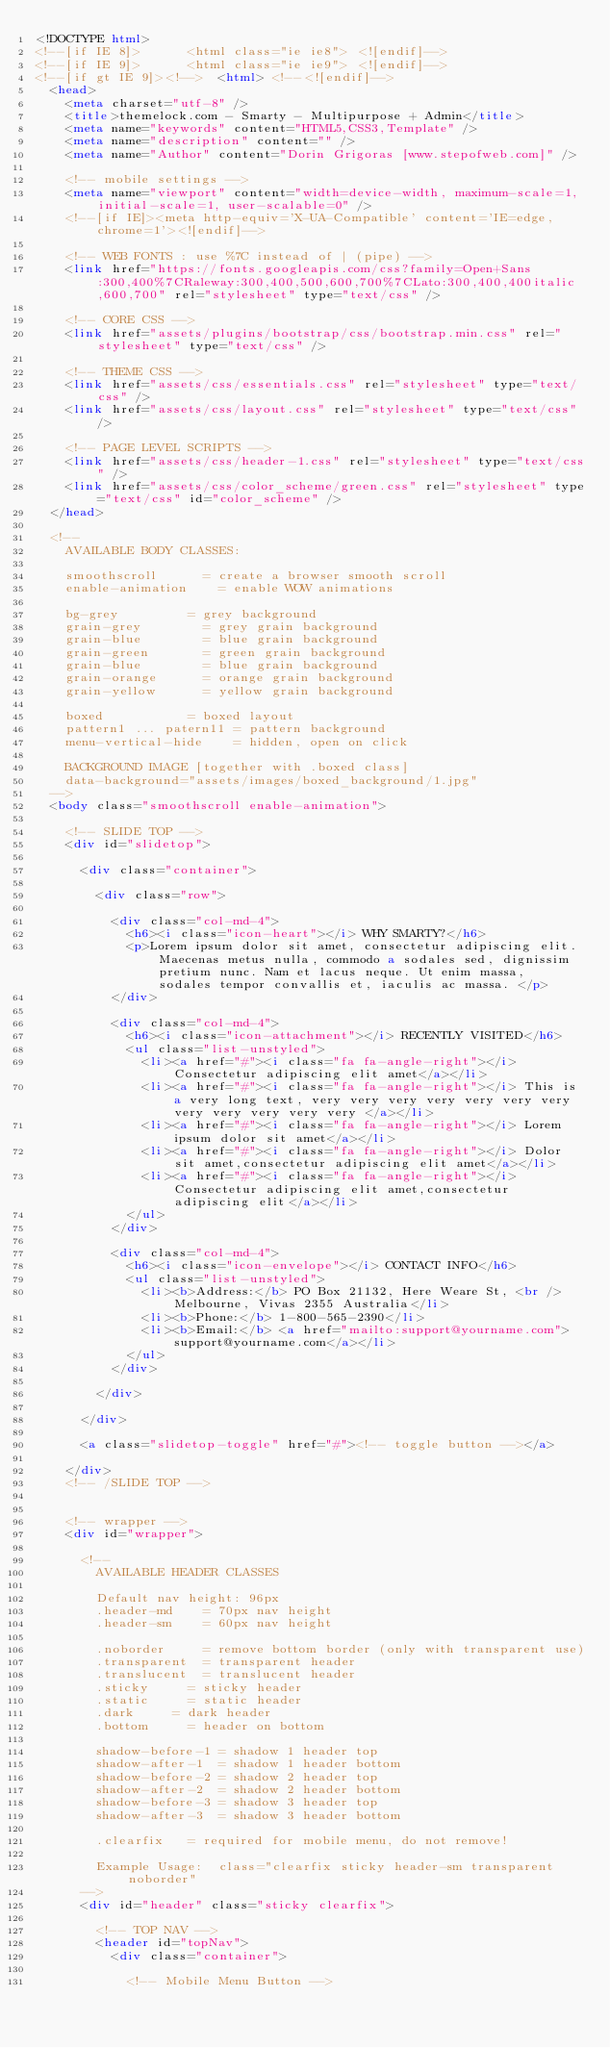Convert code to text. <code><loc_0><loc_0><loc_500><loc_500><_HTML_><!DOCTYPE html>
<!--[if IE 8]>			<html class="ie ie8"> <![endif]-->
<!--[if IE 9]>			<html class="ie ie9"> <![endif]-->
<!--[if gt IE 9]><!-->	<html> <!--<![endif]-->
	<head>
		<meta charset="utf-8" />
		<title>themelock.com - Smarty - Multipurpose + Admin</title>
		<meta name="keywords" content="HTML5,CSS3,Template" />
		<meta name="description" content="" />
		<meta name="Author" content="Dorin Grigoras [www.stepofweb.com]" />

		<!-- mobile settings -->
		<meta name="viewport" content="width=device-width, maximum-scale=1, initial-scale=1, user-scalable=0" />
		<!--[if IE]><meta http-equiv='X-UA-Compatible' content='IE=edge,chrome=1'><![endif]-->

		<!-- WEB FONTS : use %7C instead of | (pipe) -->
		<link href="https://fonts.googleapis.com/css?family=Open+Sans:300,400%7CRaleway:300,400,500,600,700%7CLato:300,400,400italic,600,700" rel="stylesheet" type="text/css" />

		<!-- CORE CSS -->
		<link href="assets/plugins/bootstrap/css/bootstrap.min.css" rel="stylesheet" type="text/css" />
		
		<!-- THEME CSS -->
		<link href="assets/css/essentials.css" rel="stylesheet" type="text/css" />
		<link href="assets/css/layout.css" rel="stylesheet" type="text/css" />

		<!-- PAGE LEVEL SCRIPTS -->
		<link href="assets/css/header-1.css" rel="stylesheet" type="text/css" />
		<link href="assets/css/color_scheme/green.css" rel="stylesheet" type="text/css" id="color_scheme" />
	</head>

	<!--
		AVAILABLE BODY CLASSES:
		
		smoothscroll 			= create a browser smooth scroll
		enable-animation		= enable WOW animations

		bg-grey					= grey background
		grain-grey				= grey grain background
		grain-blue				= blue grain background
		grain-green				= green grain background
		grain-blue				= blue grain background
		grain-orange			= orange grain background
		grain-yellow			= yellow grain background
		
		boxed 					= boxed layout
		pattern1 ... patern11	= pattern background
		menu-vertical-hide		= hidden, open on click
		
		BACKGROUND IMAGE [together with .boxed class]
		data-background="assets/images/boxed_background/1.jpg"
	-->
	<body class="smoothscroll enable-animation">

		<!-- SLIDE TOP -->
		<div id="slidetop">

			<div class="container">
				
				<div class="row">

					<div class="col-md-4">
						<h6><i class="icon-heart"></i> WHY SMARTY?</h6>
						<p>Lorem ipsum dolor sit amet, consectetur adipiscing elit. Maecenas metus nulla, commodo a sodales sed, dignissim pretium nunc. Nam et lacus neque. Ut enim massa, sodales tempor convallis et, iaculis ac massa. </p>
					</div>

					<div class="col-md-4">
						<h6><i class="icon-attachment"></i> RECENTLY VISITED</h6>
						<ul class="list-unstyled">
							<li><a href="#"><i class="fa fa-angle-right"></i> Consectetur adipiscing elit amet</a></li>
							<li><a href="#"><i class="fa fa-angle-right"></i> This is a very long text, very very very very very very very very very very very very </a></li>
							<li><a href="#"><i class="fa fa-angle-right"></i> Lorem ipsum dolor sit amet</a></li>
							<li><a href="#"><i class="fa fa-angle-right"></i> Dolor sit amet,consectetur adipiscing elit amet</a></li>
							<li><a href="#"><i class="fa fa-angle-right"></i> Consectetur adipiscing elit amet,consectetur adipiscing elit</a></li>
						</ul>
					</div>

					<div class="col-md-4">
						<h6><i class="icon-envelope"></i> CONTACT INFO</h6>
						<ul class="list-unstyled">
							<li><b>Address:</b> PO Box 21132, Here Weare St, <br /> Melbourne, Vivas 2355 Australia</li>
							<li><b>Phone:</b> 1-800-565-2390</li>
							<li><b>Email:</b> <a href="mailto:support@yourname.com">support@yourname.com</a></li>
						</ul>
					</div>

				</div>

			</div>

			<a class="slidetop-toggle" href="#"><!-- toggle button --></a>

		</div>
		<!-- /SLIDE TOP -->


		<!-- wrapper -->
		<div id="wrapper">

			<!-- 
				AVAILABLE HEADER CLASSES

				Default nav height: 96px
				.header-md 		= 70px nav height
				.header-sm 		= 60px nav height

				.noborder 		= remove bottom border (only with transparent use)
				.transparent	= transparent header
				.translucent	= translucent header
				.sticky			= sticky header
				.static			= static header
				.dark			= dark header
				.bottom			= header on bottom
				
				shadow-before-1 = shadow 1 header top
				shadow-after-1 	= shadow 1 header bottom
				shadow-before-2 = shadow 2 header top
				shadow-after-2 	= shadow 2 header bottom
				shadow-before-3 = shadow 3 header top
				shadow-after-3 	= shadow 3 header bottom

				.clearfix		= required for mobile menu, do not remove!

				Example Usage:  class="clearfix sticky header-sm transparent noborder"
			-->
			<div id="header" class="sticky clearfix">

				<!-- TOP NAV -->
				<header id="topNav">
					<div class="container">

						<!-- Mobile Menu Button --></code> 